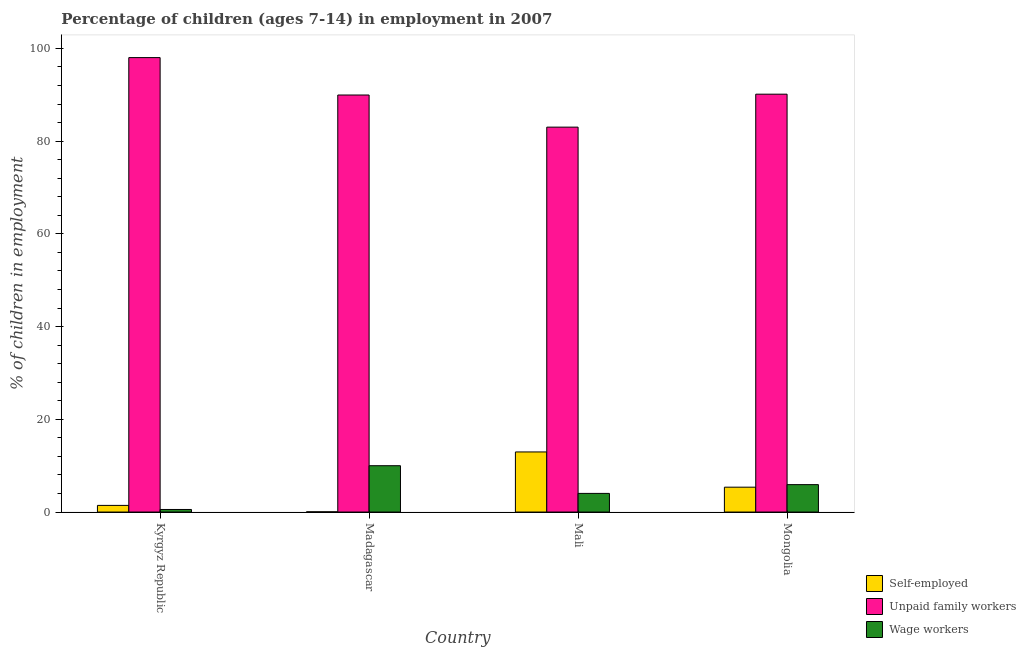How many groups of bars are there?
Your answer should be compact. 4. Are the number of bars per tick equal to the number of legend labels?
Ensure brevity in your answer.  Yes. Are the number of bars on each tick of the X-axis equal?
Provide a short and direct response. Yes. How many bars are there on the 1st tick from the left?
Your answer should be compact. 3. How many bars are there on the 2nd tick from the right?
Ensure brevity in your answer.  3. What is the label of the 3rd group of bars from the left?
Your answer should be very brief. Mali. In how many cases, is the number of bars for a given country not equal to the number of legend labels?
Make the answer very short. 0. What is the percentage of children employed as unpaid family workers in Kyrgyz Republic?
Ensure brevity in your answer.  98.02. Across all countries, what is the maximum percentage of self employed children?
Give a very brief answer. 12.96. Across all countries, what is the minimum percentage of children employed as wage workers?
Offer a very short reply. 0.55. In which country was the percentage of children employed as wage workers maximum?
Keep it short and to the point. Madagascar. In which country was the percentage of children employed as wage workers minimum?
Offer a terse response. Kyrgyz Republic. What is the total percentage of children employed as wage workers in the graph?
Keep it short and to the point. 20.47. What is the difference between the percentage of children employed as unpaid family workers in Madagascar and that in Mongolia?
Provide a short and direct response. -0.18. What is the difference between the percentage of self employed children in Madagascar and the percentage of children employed as unpaid family workers in Mongolia?
Give a very brief answer. -90.08. What is the average percentage of children employed as unpaid family workers per country?
Offer a very short reply. 90.28. What is the difference between the percentage of children employed as wage workers and percentage of self employed children in Madagascar?
Offer a terse response. 9.94. What is the ratio of the percentage of children employed as wage workers in Kyrgyz Republic to that in Madagascar?
Provide a succinct answer. 0.06. Is the difference between the percentage of children employed as unpaid family workers in Kyrgyz Republic and Mongolia greater than the difference between the percentage of children employed as wage workers in Kyrgyz Republic and Mongolia?
Provide a succinct answer. Yes. What is the difference between the highest and the second highest percentage of children employed as wage workers?
Give a very brief answer. 4.08. In how many countries, is the percentage of children employed as wage workers greater than the average percentage of children employed as wage workers taken over all countries?
Ensure brevity in your answer.  2. Is the sum of the percentage of children employed as wage workers in Kyrgyz Republic and Madagascar greater than the maximum percentage of self employed children across all countries?
Provide a succinct answer. No. What does the 3rd bar from the left in Madagascar represents?
Keep it short and to the point. Wage workers. What does the 3rd bar from the right in Mongolia represents?
Your answer should be very brief. Self-employed. Is it the case that in every country, the sum of the percentage of self employed children and percentage of children employed as unpaid family workers is greater than the percentage of children employed as wage workers?
Provide a short and direct response. Yes. Does the graph contain grids?
Make the answer very short. No. How many legend labels are there?
Keep it short and to the point. 3. What is the title of the graph?
Offer a very short reply. Percentage of children (ages 7-14) in employment in 2007. What is the label or title of the Y-axis?
Your answer should be very brief. % of children in employment. What is the % of children in employment of Self-employed in Kyrgyz Republic?
Offer a very short reply. 1.43. What is the % of children in employment of Unpaid family workers in Kyrgyz Republic?
Offer a very short reply. 98.02. What is the % of children in employment of Wage workers in Kyrgyz Republic?
Ensure brevity in your answer.  0.55. What is the % of children in employment in Self-employed in Madagascar?
Give a very brief answer. 0.05. What is the % of children in employment in Unpaid family workers in Madagascar?
Give a very brief answer. 89.95. What is the % of children in employment in Wage workers in Madagascar?
Make the answer very short. 9.99. What is the % of children in employment of Self-employed in Mali?
Provide a short and direct response. 12.96. What is the % of children in employment in Unpaid family workers in Mali?
Your answer should be very brief. 83.02. What is the % of children in employment of Wage workers in Mali?
Your answer should be compact. 4.02. What is the % of children in employment of Self-employed in Mongolia?
Give a very brief answer. 5.36. What is the % of children in employment of Unpaid family workers in Mongolia?
Your response must be concise. 90.13. What is the % of children in employment in Wage workers in Mongolia?
Offer a terse response. 5.91. Across all countries, what is the maximum % of children in employment in Self-employed?
Make the answer very short. 12.96. Across all countries, what is the maximum % of children in employment in Unpaid family workers?
Offer a terse response. 98.02. Across all countries, what is the maximum % of children in employment of Wage workers?
Ensure brevity in your answer.  9.99. Across all countries, what is the minimum % of children in employment in Self-employed?
Provide a short and direct response. 0.05. Across all countries, what is the minimum % of children in employment in Unpaid family workers?
Offer a very short reply. 83.02. Across all countries, what is the minimum % of children in employment of Wage workers?
Provide a succinct answer. 0.55. What is the total % of children in employment of Self-employed in the graph?
Keep it short and to the point. 19.8. What is the total % of children in employment of Unpaid family workers in the graph?
Your answer should be compact. 361.12. What is the total % of children in employment in Wage workers in the graph?
Make the answer very short. 20.47. What is the difference between the % of children in employment in Self-employed in Kyrgyz Republic and that in Madagascar?
Your answer should be compact. 1.38. What is the difference between the % of children in employment in Unpaid family workers in Kyrgyz Republic and that in Madagascar?
Offer a very short reply. 8.07. What is the difference between the % of children in employment of Wage workers in Kyrgyz Republic and that in Madagascar?
Give a very brief answer. -9.44. What is the difference between the % of children in employment of Self-employed in Kyrgyz Republic and that in Mali?
Give a very brief answer. -11.53. What is the difference between the % of children in employment of Unpaid family workers in Kyrgyz Republic and that in Mali?
Give a very brief answer. 15. What is the difference between the % of children in employment of Wage workers in Kyrgyz Republic and that in Mali?
Give a very brief answer. -3.47. What is the difference between the % of children in employment of Self-employed in Kyrgyz Republic and that in Mongolia?
Make the answer very short. -3.93. What is the difference between the % of children in employment of Unpaid family workers in Kyrgyz Republic and that in Mongolia?
Offer a terse response. 7.89. What is the difference between the % of children in employment in Wage workers in Kyrgyz Republic and that in Mongolia?
Ensure brevity in your answer.  -5.36. What is the difference between the % of children in employment in Self-employed in Madagascar and that in Mali?
Ensure brevity in your answer.  -12.91. What is the difference between the % of children in employment of Unpaid family workers in Madagascar and that in Mali?
Give a very brief answer. 6.93. What is the difference between the % of children in employment in Wage workers in Madagascar and that in Mali?
Give a very brief answer. 5.97. What is the difference between the % of children in employment of Self-employed in Madagascar and that in Mongolia?
Provide a succinct answer. -5.31. What is the difference between the % of children in employment in Unpaid family workers in Madagascar and that in Mongolia?
Your response must be concise. -0.18. What is the difference between the % of children in employment of Wage workers in Madagascar and that in Mongolia?
Keep it short and to the point. 4.08. What is the difference between the % of children in employment in Self-employed in Mali and that in Mongolia?
Your answer should be compact. 7.6. What is the difference between the % of children in employment of Unpaid family workers in Mali and that in Mongolia?
Ensure brevity in your answer.  -7.11. What is the difference between the % of children in employment of Wage workers in Mali and that in Mongolia?
Offer a very short reply. -1.89. What is the difference between the % of children in employment of Self-employed in Kyrgyz Republic and the % of children in employment of Unpaid family workers in Madagascar?
Keep it short and to the point. -88.52. What is the difference between the % of children in employment in Self-employed in Kyrgyz Republic and the % of children in employment in Wage workers in Madagascar?
Your response must be concise. -8.56. What is the difference between the % of children in employment of Unpaid family workers in Kyrgyz Republic and the % of children in employment of Wage workers in Madagascar?
Provide a short and direct response. 88.03. What is the difference between the % of children in employment in Self-employed in Kyrgyz Republic and the % of children in employment in Unpaid family workers in Mali?
Your response must be concise. -81.59. What is the difference between the % of children in employment of Self-employed in Kyrgyz Republic and the % of children in employment of Wage workers in Mali?
Give a very brief answer. -2.59. What is the difference between the % of children in employment of Unpaid family workers in Kyrgyz Republic and the % of children in employment of Wage workers in Mali?
Keep it short and to the point. 94. What is the difference between the % of children in employment of Self-employed in Kyrgyz Republic and the % of children in employment of Unpaid family workers in Mongolia?
Keep it short and to the point. -88.7. What is the difference between the % of children in employment of Self-employed in Kyrgyz Republic and the % of children in employment of Wage workers in Mongolia?
Your answer should be compact. -4.48. What is the difference between the % of children in employment of Unpaid family workers in Kyrgyz Republic and the % of children in employment of Wage workers in Mongolia?
Your response must be concise. 92.11. What is the difference between the % of children in employment of Self-employed in Madagascar and the % of children in employment of Unpaid family workers in Mali?
Provide a short and direct response. -82.97. What is the difference between the % of children in employment in Self-employed in Madagascar and the % of children in employment in Wage workers in Mali?
Provide a short and direct response. -3.97. What is the difference between the % of children in employment of Unpaid family workers in Madagascar and the % of children in employment of Wage workers in Mali?
Offer a very short reply. 85.93. What is the difference between the % of children in employment in Self-employed in Madagascar and the % of children in employment in Unpaid family workers in Mongolia?
Keep it short and to the point. -90.08. What is the difference between the % of children in employment in Self-employed in Madagascar and the % of children in employment in Wage workers in Mongolia?
Keep it short and to the point. -5.86. What is the difference between the % of children in employment of Unpaid family workers in Madagascar and the % of children in employment of Wage workers in Mongolia?
Offer a very short reply. 84.04. What is the difference between the % of children in employment in Self-employed in Mali and the % of children in employment in Unpaid family workers in Mongolia?
Make the answer very short. -77.17. What is the difference between the % of children in employment in Self-employed in Mali and the % of children in employment in Wage workers in Mongolia?
Provide a succinct answer. 7.05. What is the difference between the % of children in employment of Unpaid family workers in Mali and the % of children in employment of Wage workers in Mongolia?
Offer a terse response. 77.11. What is the average % of children in employment of Self-employed per country?
Your response must be concise. 4.95. What is the average % of children in employment in Unpaid family workers per country?
Offer a very short reply. 90.28. What is the average % of children in employment of Wage workers per country?
Offer a terse response. 5.12. What is the difference between the % of children in employment in Self-employed and % of children in employment in Unpaid family workers in Kyrgyz Republic?
Keep it short and to the point. -96.59. What is the difference between the % of children in employment in Unpaid family workers and % of children in employment in Wage workers in Kyrgyz Republic?
Offer a very short reply. 97.47. What is the difference between the % of children in employment in Self-employed and % of children in employment in Unpaid family workers in Madagascar?
Provide a short and direct response. -89.9. What is the difference between the % of children in employment in Self-employed and % of children in employment in Wage workers in Madagascar?
Offer a very short reply. -9.94. What is the difference between the % of children in employment in Unpaid family workers and % of children in employment in Wage workers in Madagascar?
Offer a very short reply. 79.96. What is the difference between the % of children in employment of Self-employed and % of children in employment of Unpaid family workers in Mali?
Provide a short and direct response. -70.06. What is the difference between the % of children in employment of Self-employed and % of children in employment of Wage workers in Mali?
Your response must be concise. 8.94. What is the difference between the % of children in employment of Unpaid family workers and % of children in employment of Wage workers in Mali?
Make the answer very short. 79. What is the difference between the % of children in employment in Self-employed and % of children in employment in Unpaid family workers in Mongolia?
Ensure brevity in your answer.  -84.77. What is the difference between the % of children in employment of Self-employed and % of children in employment of Wage workers in Mongolia?
Your response must be concise. -0.55. What is the difference between the % of children in employment in Unpaid family workers and % of children in employment in Wage workers in Mongolia?
Offer a very short reply. 84.22. What is the ratio of the % of children in employment of Self-employed in Kyrgyz Republic to that in Madagascar?
Your answer should be compact. 28.6. What is the ratio of the % of children in employment in Unpaid family workers in Kyrgyz Republic to that in Madagascar?
Offer a very short reply. 1.09. What is the ratio of the % of children in employment in Wage workers in Kyrgyz Republic to that in Madagascar?
Give a very brief answer. 0.06. What is the ratio of the % of children in employment in Self-employed in Kyrgyz Republic to that in Mali?
Make the answer very short. 0.11. What is the ratio of the % of children in employment in Unpaid family workers in Kyrgyz Republic to that in Mali?
Keep it short and to the point. 1.18. What is the ratio of the % of children in employment in Wage workers in Kyrgyz Republic to that in Mali?
Offer a terse response. 0.14. What is the ratio of the % of children in employment in Self-employed in Kyrgyz Republic to that in Mongolia?
Ensure brevity in your answer.  0.27. What is the ratio of the % of children in employment in Unpaid family workers in Kyrgyz Republic to that in Mongolia?
Your answer should be very brief. 1.09. What is the ratio of the % of children in employment in Wage workers in Kyrgyz Republic to that in Mongolia?
Ensure brevity in your answer.  0.09. What is the ratio of the % of children in employment of Self-employed in Madagascar to that in Mali?
Your answer should be compact. 0. What is the ratio of the % of children in employment in Unpaid family workers in Madagascar to that in Mali?
Ensure brevity in your answer.  1.08. What is the ratio of the % of children in employment of Wage workers in Madagascar to that in Mali?
Give a very brief answer. 2.49. What is the ratio of the % of children in employment in Self-employed in Madagascar to that in Mongolia?
Your answer should be very brief. 0.01. What is the ratio of the % of children in employment in Unpaid family workers in Madagascar to that in Mongolia?
Give a very brief answer. 1. What is the ratio of the % of children in employment in Wage workers in Madagascar to that in Mongolia?
Your answer should be very brief. 1.69. What is the ratio of the % of children in employment in Self-employed in Mali to that in Mongolia?
Offer a very short reply. 2.42. What is the ratio of the % of children in employment in Unpaid family workers in Mali to that in Mongolia?
Provide a succinct answer. 0.92. What is the ratio of the % of children in employment in Wage workers in Mali to that in Mongolia?
Your answer should be very brief. 0.68. What is the difference between the highest and the second highest % of children in employment in Unpaid family workers?
Ensure brevity in your answer.  7.89. What is the difference between the highest and the second highest % of children in employment of Wage workers?
Ensure brevity in your answer.  4.08. What is the difference between the highest and the lowest % of children in employment of Self-employed?
Offer a very short reply. 12.91. What is the difference between the highest and the lowest % of children in employment in Unpaid family workers?
Your answer should be very brief. 15. What is the difference between the highest and the lowest % of children in employment of Wage workers?
Provide a short and direct response. 9.44. 